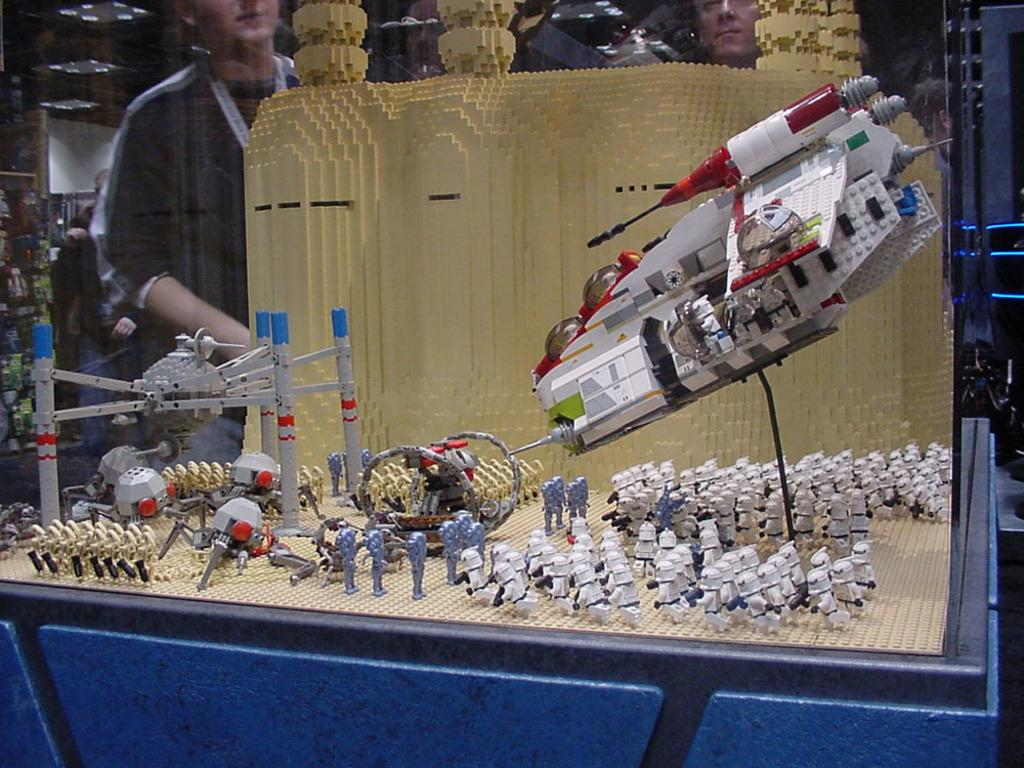What is the main subject of the image? The main subject of the image is a model made with blocks. What types of objects are included in the model? The model includes soldiers, war weapons, tankers, and other machines. Can you describe the person in the image? There is a person standing in the back of the model, and they are wearing a tag. What type of skate is being used by the soldiers in the model? There are no skates present in the image; it is a model of a military scene with soldiers, war weapons, tankers, and other machines. What is the cause of the conflict depicted in the model? The image is a model and does not depict an actual conflict, so it is not possible to determine the cause of any conflict from the image. 